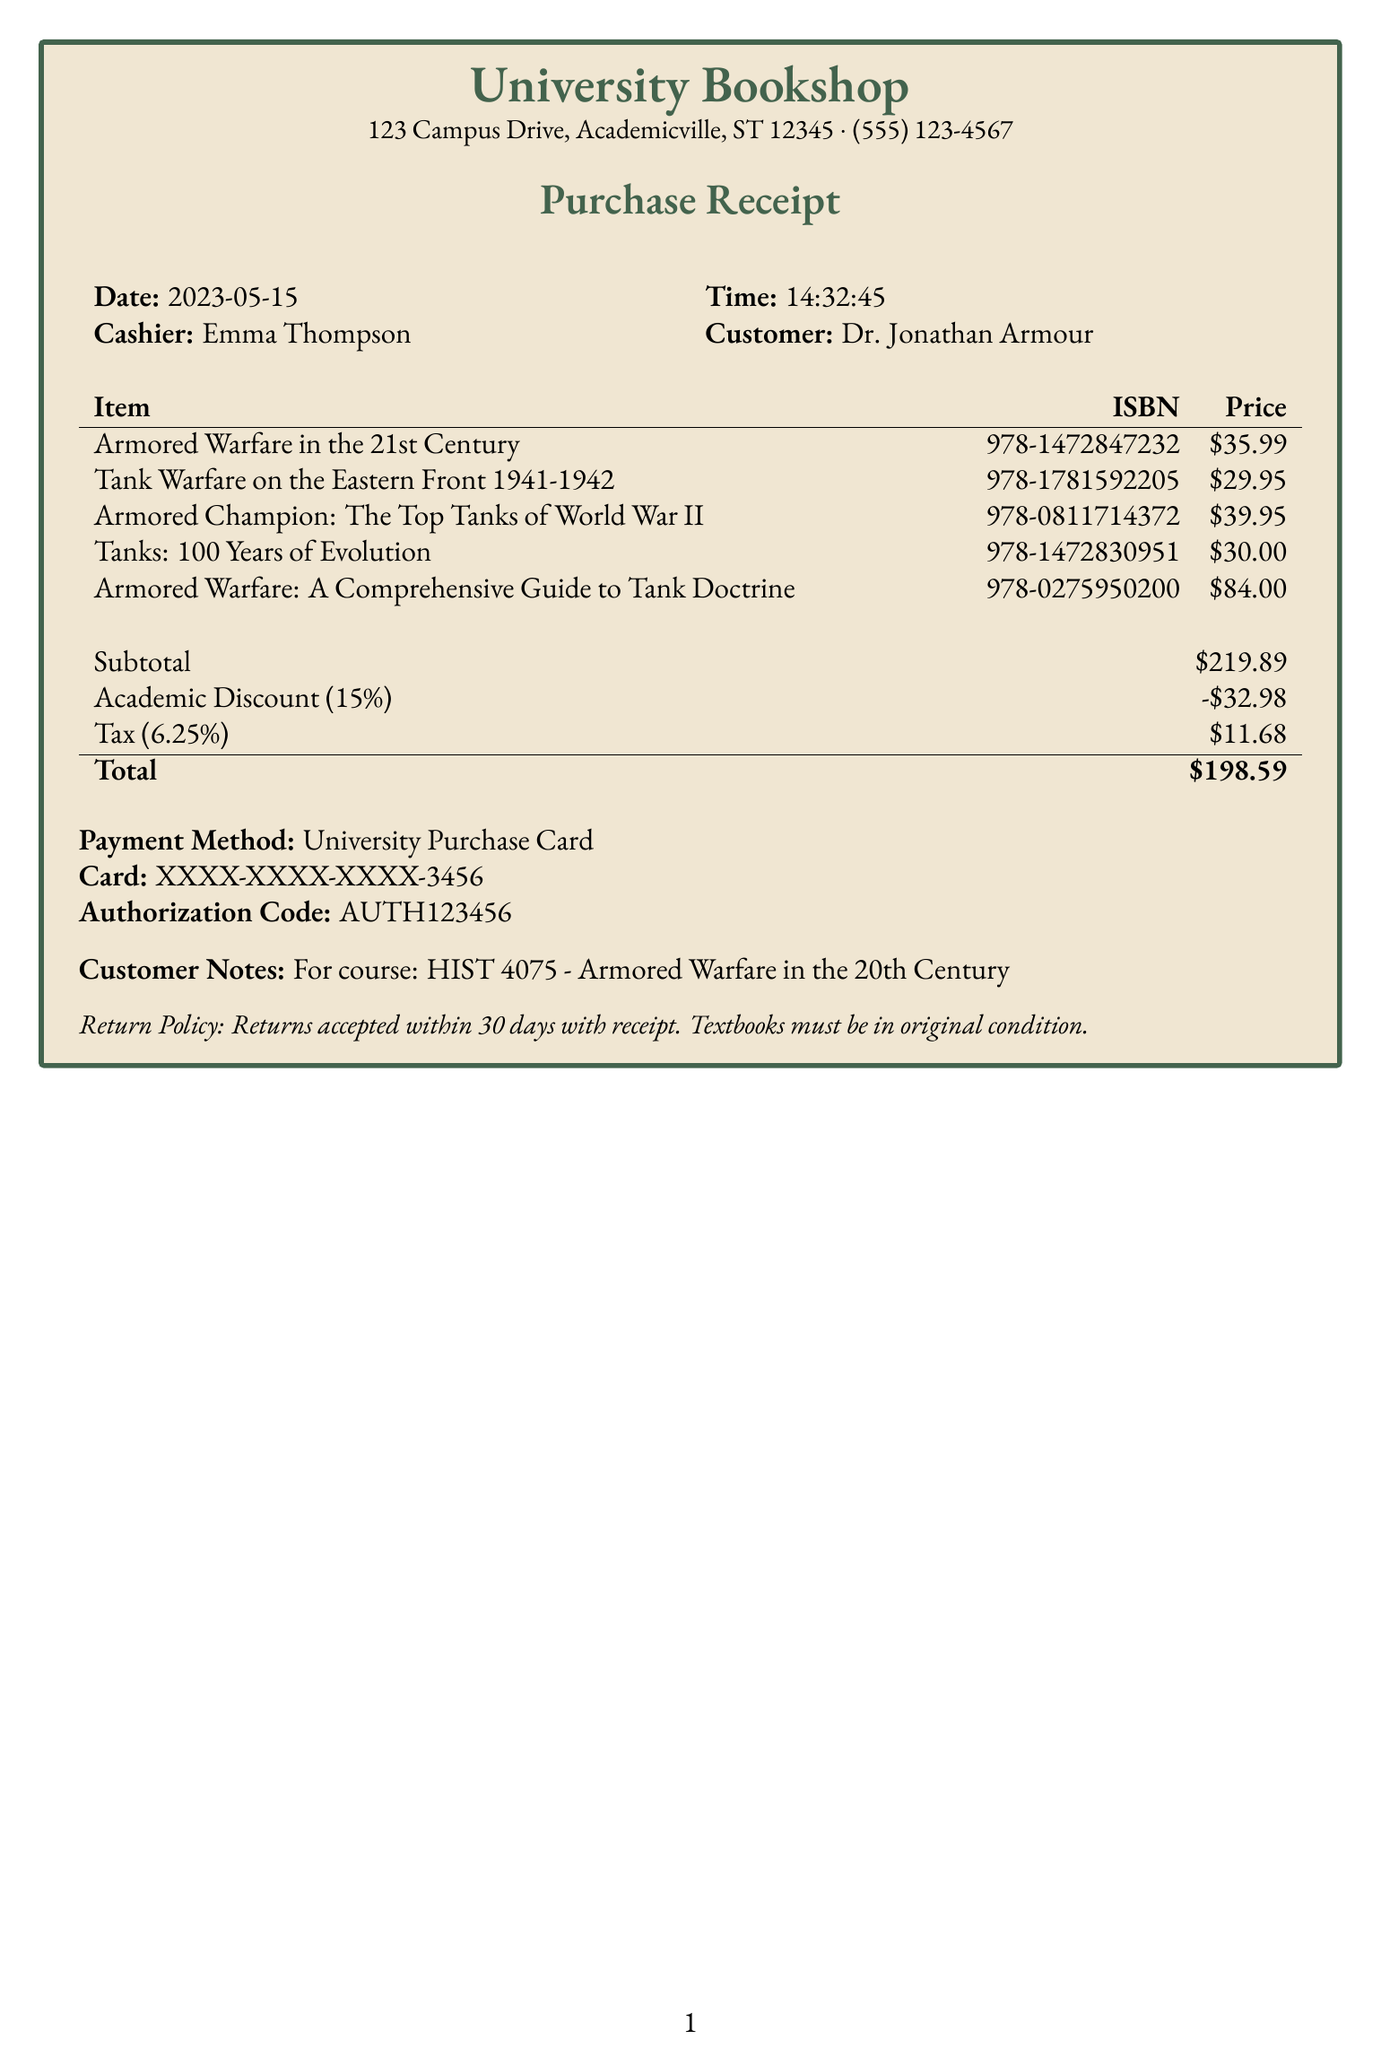What is the total amount paid? The total amount can be found at the bottom of the receipt, which states the total after discounts and tax, amounting to $198.59.
Answer: $198.59 Who is the cashier? The cashier's name is mentioned at the specified location in the document, identified as Emma Thompson.
Answer: Emma Thompson What is the date of purchase? The date of purchase is displayed near the top of the receipt, specifically listed as 2023-05-15.
Answer: 2023-05-15 What is the academic discount percentage? The document indicates the applied academic discount as 15%, clearly outlined under the subtotal section.
Answer: 15% What is the return policy? The return policy is presented towards the end of the receipt, stating the conditions for returning items purchased.
Answer: Returns accepted within 30 days with receipt How many items were purchased? By counting the items listed in the receipt, the total number of different titles can be noted, which adds up to five individual titles.
Answer: 5 What course is the purchase for? The customer notes at the bottom of the receipt indicate the specific course related to this purchase, which is HIST 4075.
Answer: HIST 4075 What is the subtotal amount before discounts? The subtotal can be found in the summary section of the receipt, shown as $219.89 before any discounts are applied.
Answer: $219.89 What payment method was used? The method of payment is stated clearly within the document; it notes the use of a University Purchase Card for this transaction.
Answer: University Purchase Card 